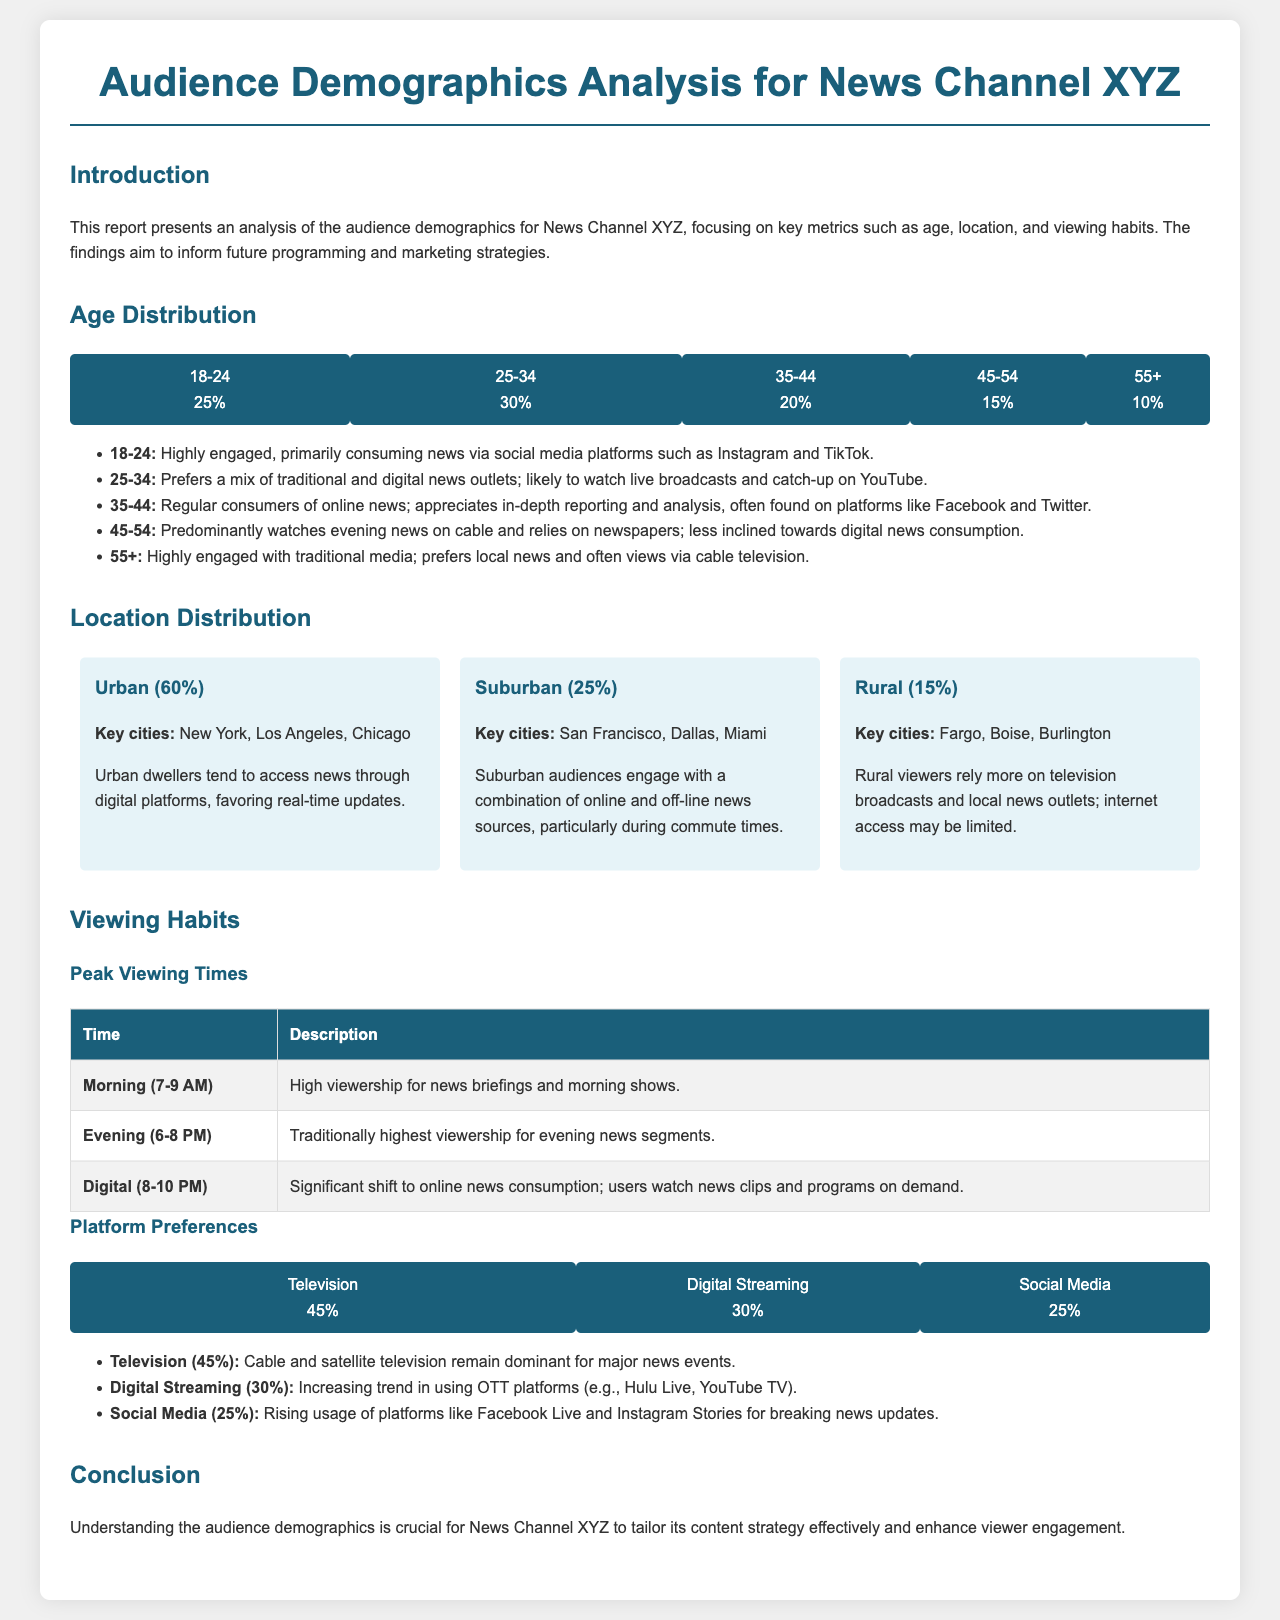What is the primary age group watching the news channel? The primary age group is the one with the highest percentage in the age distribution, which is 25-34 at 30%.
Answer: 25-34 What percentage of the audience is from urban areas? The percentage of the audience from urban areas is provided in the location distribution section, which states 60%.
Answer: 60% Which platform has the highest viewing preference? The platform with the highest viewing preference is mentioned in the viewing habits section, which is television at 45%.
Answer: Television What time has the highest viewership for evening news? The time with the highest viewership for evening news is specified in the peak viewing times table as 6-8 PM.
Answer: 6-8 PM Which two age groups consume news through social media? The age groups that consume news through social media are specified as 18-24 and 25-34.
Answer: 18-24, 25-34 What is the total percentage of rural audience? The total percentage of the rural audience is given in the location distribution section, which is 15%.
Answer: 15% During which time is there a significant shift to online news consumption? The time of the significant shift to online news consumption is indicated as 8-10 PM in the peak viewing times section.
Answer: 8-10 PM What percentage of the audience is likely to watch evening news on cable? The percentage of the audience likely to watch evening news on cable is provided in the viewing habits section, noted as 45%.
Answer: 45% What demographic mainly watches news via social media platforms like TikTok? The demographic that mainly watches news via social media platforms like TikTok is specified as 18-24 years old.
Answer: 18-24 